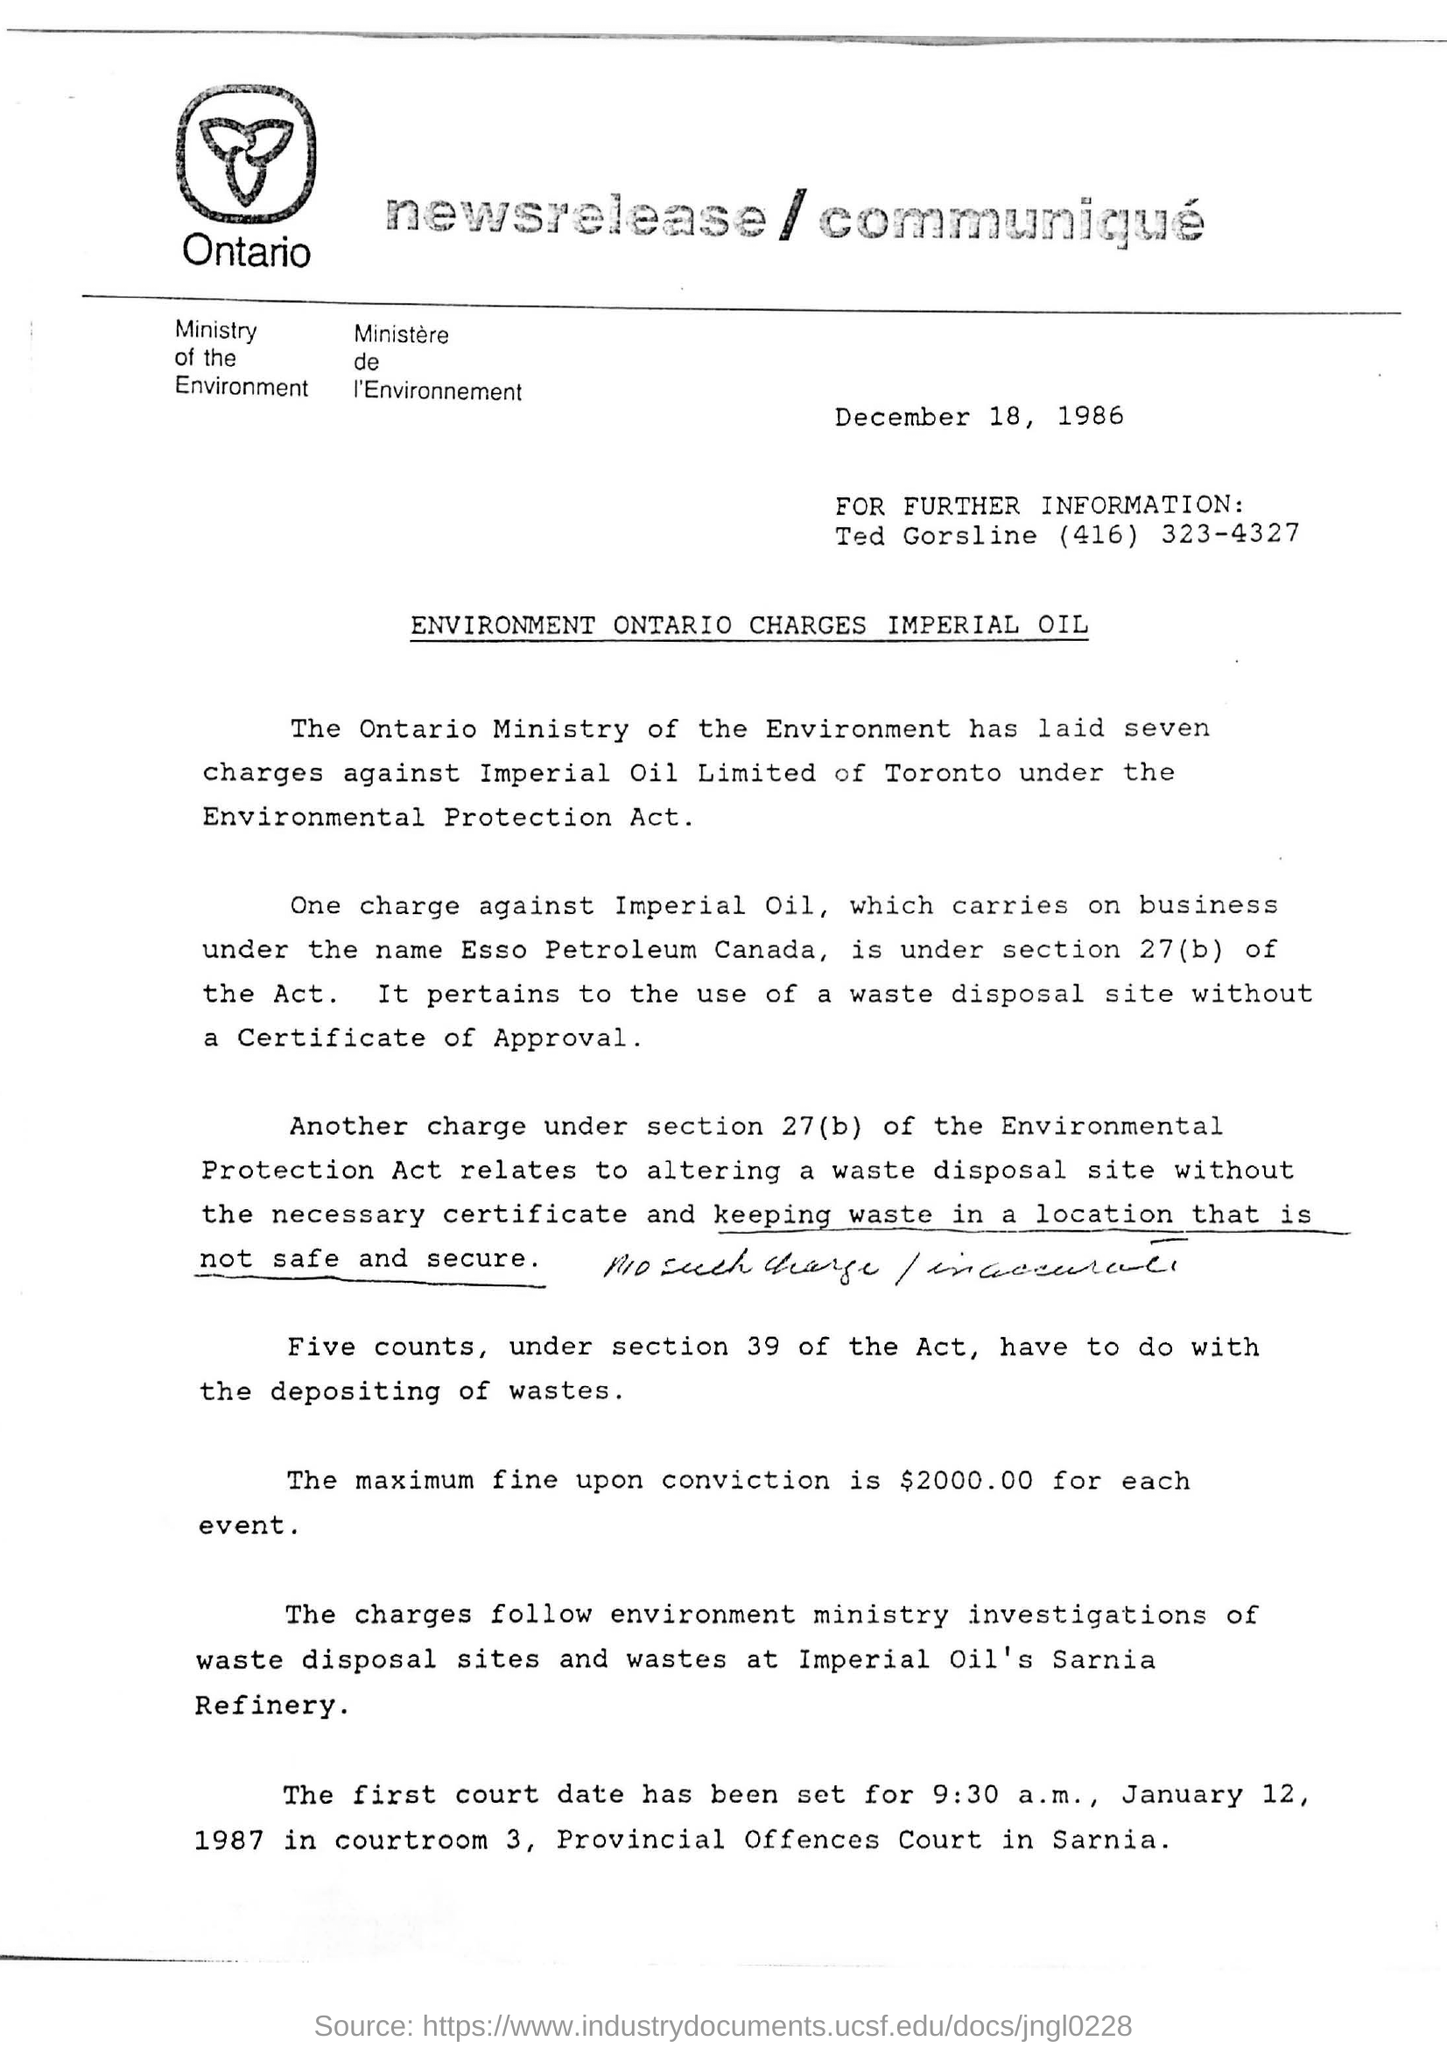Draw attention to some important aspects in this diagram. The maximum fine that can be imposed upon conviction for each event is $2000.00. The Ontario Ministry has laid seven charges. Esso petroleum is located in Canada. 